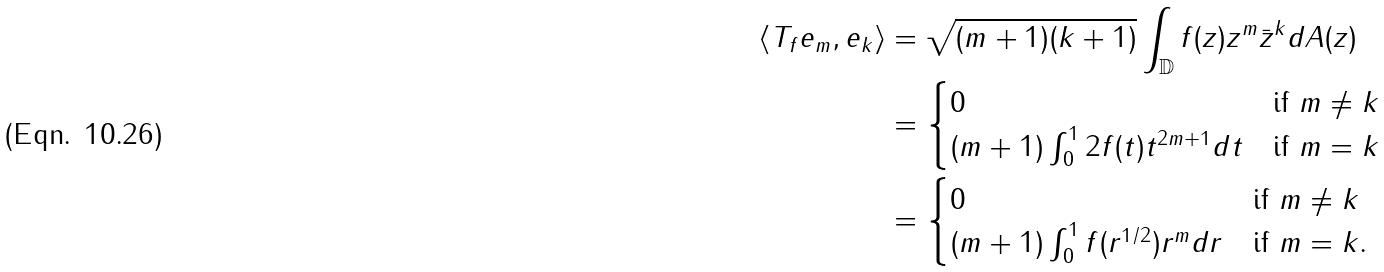<formula> <loc_0><loc_0><loc_500><loc_500>\langle T _ { f } e _ { m } , e _ { k } \rangle & = \sqrt { ( m + 1 ) ( k + 1 ) } \int _ { \mathbb { D } } f ( z ) z ^ { m } \bar { z } ^ { k } d A ( z ) \\ & = \begin{cases} 0 & \text {if } m \neq k \\ ( m + 1 ) \int _ { 0 } ^ { 1 } 2 f ( t ) t ^ { 2 m + 1 } d t & \text {if } m = k \end{cases} \\ & = \begin{cases} 0 & \text {if } m \neq k \\ ( m + 1 ) \int _ { 0 } ^ { 1 } f ( r ^ { 1 / 2 } ) r ^ { m } d r & \text {if } m = k . \end{cases}</formula> 